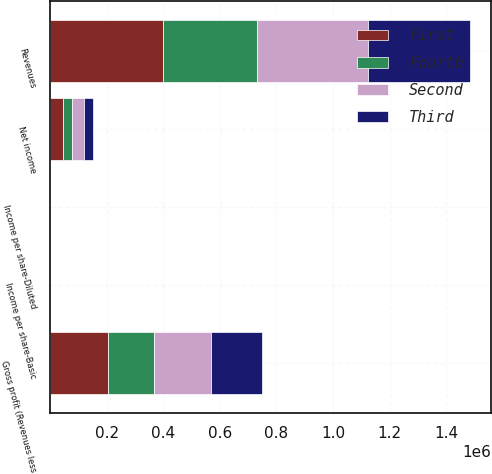Convert chart to OTSL. <chart><loc_0><loc_0><loc_500><loc_500><stacked_bar_chart><ecel><fcel>Revenues<fcel>Gross profit (Revenues less<fcel>Net income<fcel>Income per share-Basic<fcel>Income per share-Diluted<nl><fcel>Fourth<fcel>330909<fcel>162866<fcel>30281<fcel>0.14<fcel>0.14<nl><fcel>Second<fcel>392150<fcel>201941<fcel>45073<fcel>0.21<fcel>0.21<nl><fcel>First<fcel>399746<fcel>204257<fcel>45046<fcel>0.21<fcel>0.21<nl><fcel>Third<fcel>362500<fcel>180265<fcel>31749<fcel>0.15<fcel>0.15<nl></chart> 